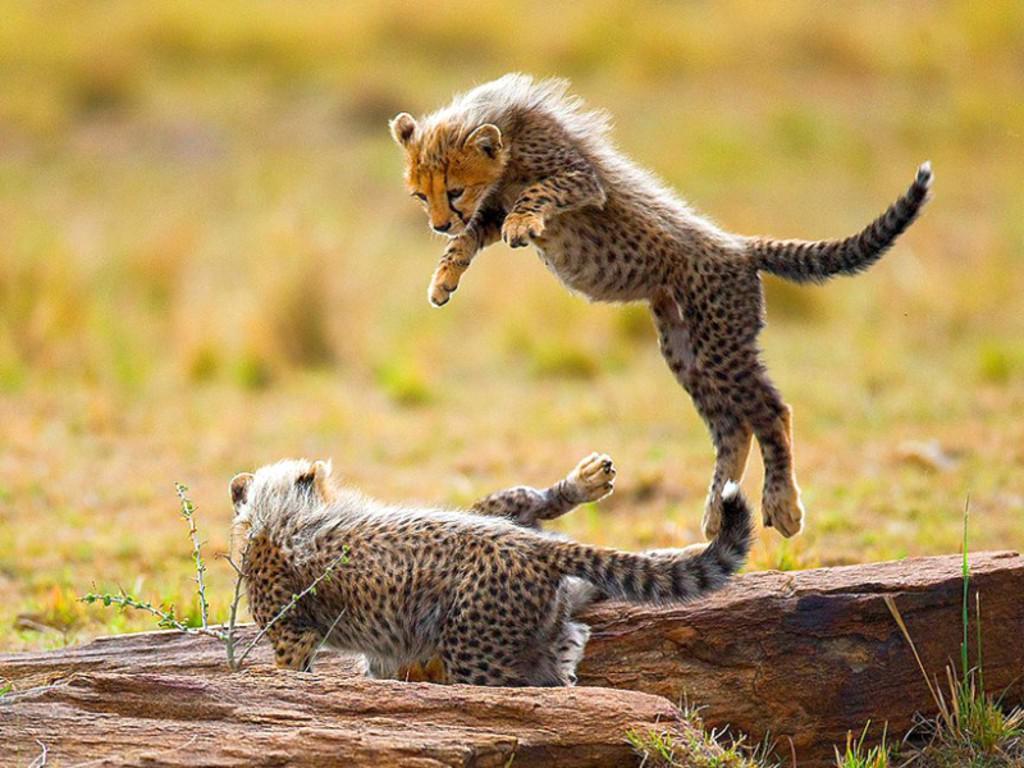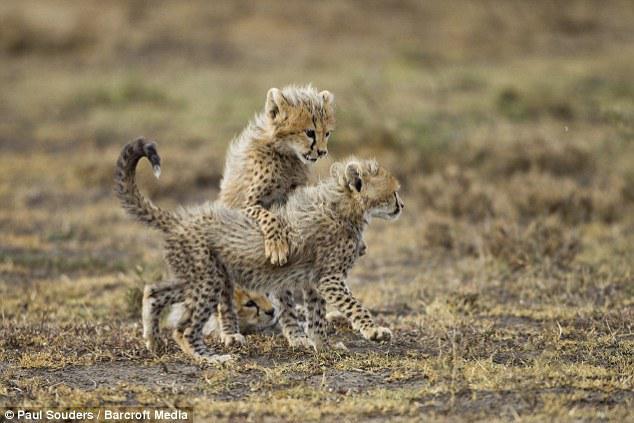The first image is the image on the left, the second image is the image on the right. Considering the images on both sides, is "One image has a wild cat in the middle of pouncing onto another wild cat." valid? Answer yes or no. Yes. 